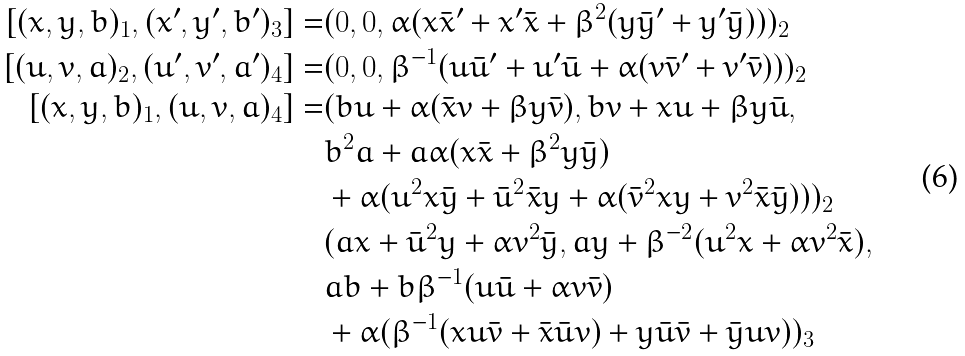<formula> <loc_0><loc_0><loc_500><loc_500>[ ( x , y , b ) _ { 1 } , ( x ^ { \prime } , y ^ { \prime } , b ^ { \prime } ) _ { 3 } ] = & ( 0 , 0 , \alpha ( x \bar { x } ^ { \prime } + x ^ { \prime } \bar { x } + \beta ^ { 2 } ( y \bar { y } ^ { \prime } + y ^ { \prime } \bar { y } ) ) ) _ { 2 } \\ [ ( u , v , a ) _ { 2 } , ( u ^ { \prime } , v ^ { \prime } , a ^ { \prime } ) _ { 4 } ] = & ( 0 , 0 , \beta ^ { - 1 } ( u \bar { u } ^ { \prime } + u ^ { \prime } \bar { u } + \alpha ( v \bar { v } ^ { \prime } + v ^ { \prime } \bar { v } ) ) ) _ { 2 } \\ [ ( x , y , b ) _ { 1 } , ( u , v , a ) _ { 4 } ] = & ( b u + \alpha ( \bar { x } v + \beta y \bar { v } ) , b v + x u + \beta y \bar { u } , \\ & b ^ { 2 } a + a \alpha ( x \bar { x } + \beta ^ { 2 } y \bar { y } ) \\ & + \alpha ( u ^ { 2 } x \bar { y } + \bar { u } ^ { 2 } \bar { x } y + \alpha ( \bar { v } ^ { 2 } x y + v ^ { 2 } \bar { x } \bar { y } ) ) ) _ { 2 } \\ & ( a x + \bar { u } ^ { 2 } y + \alpha v ^ { 2 } \bar { y } , a y + \beta ^ { - 2 } ( u ^ { 2 } x + \alpha v ^ { 2 } \bar { x } ) , \\ & a b + b \beta ^ { - 1 } ( u \bar { u } + \alpha v \bar { v } ) \\ & + \alpha ( \beta ^ { - 1 } ( x u \bar { v } + \bar { x } \bar { u } v ) + y \bar { u } \bar { v } + \bar { y } u v ) ) _ { 3 }</formula> 